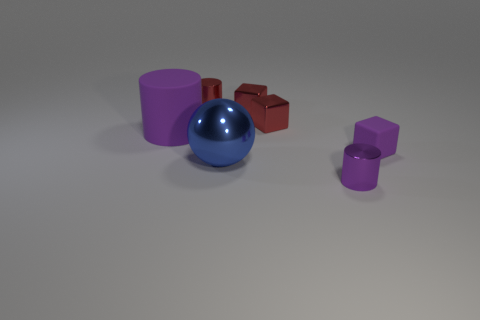Do the matte cylinder and the small rubber cube have the same color?
Keep it short and to the point. Yes. There is a large thing that is the same shape as the tiny purple metallic thing; what color is it?
Ensure brevity in your answer.  Purple. What number of large matte things have the same color as the big ball?
Offer a very short reply. 0. What is the color of the cylinder in front of the purple cylinder that is behind the tiny purple thing on the left side of the purple block?
Your response must be concise. Purple. Are the sphere and the tiny purple cylinder made of the same material?
Keep it short and to the point. Yes. Do the large purple rubber object and the purple shiny object have the same shape?
Your response must be concise. Yes. Are there an equal number of metal cylinders in front of the tiny rubber thing and tiny metal objects in front of the large blue object?
Keep it short and to the point. Yes. The other object that is the same material as the big purple object is what color?
Keep it short and to the point. Purple. How many purple blocks have the same material as the small purple cylinder?
Ensure brevity in your answer.  0. Is the color of the matte thing on the right side of the small purple shiny thing the same as the matte cylinder?
Offer a very short reply. Yes. 